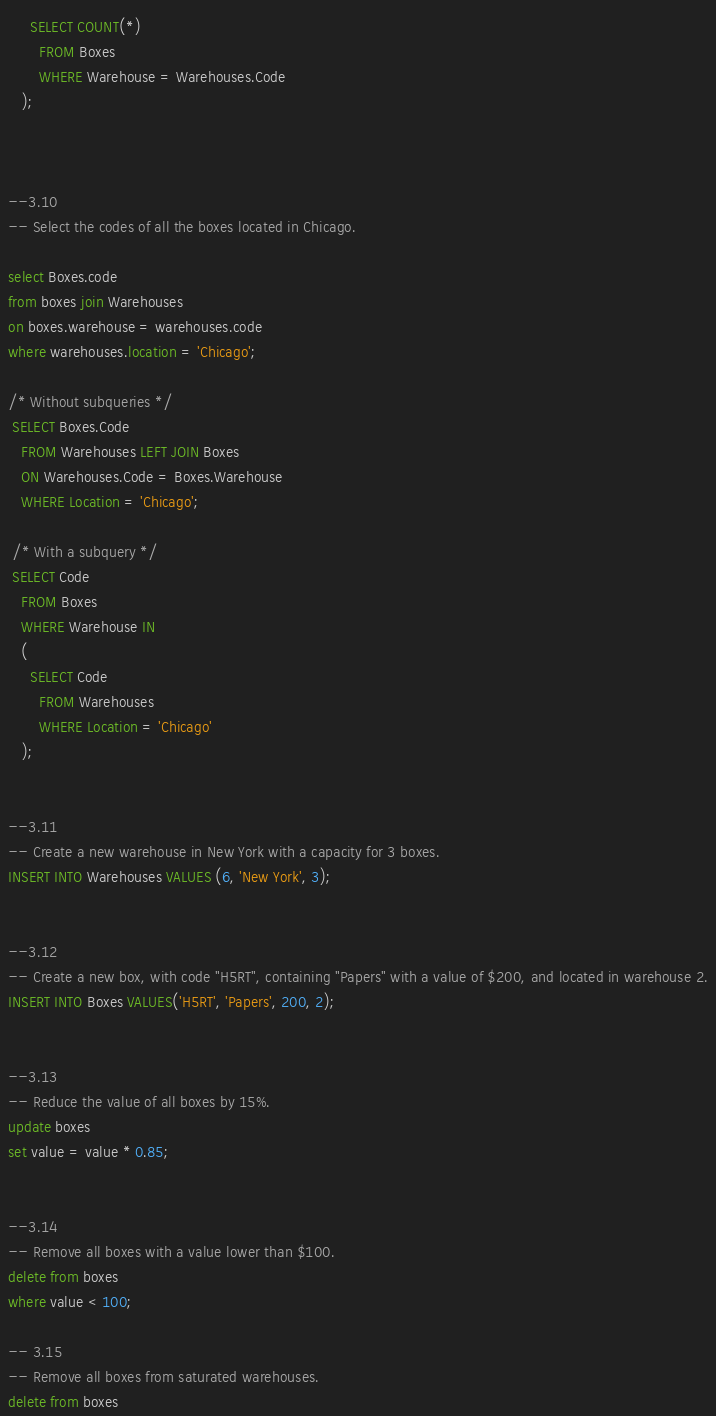Convert code to text. <code><loc_0><loc_0><loc_500><loc_500><_SQL_>     SELECT COUNT(*)
       FROM Boxes
       WHERE Warehouse = Warehouses.Code
   );



--3.10
-- Select the codes of all the boxes located in Chicago.

select Boxes.code 
from boxes join Warehouses
on boxes.warehouse = warehouses.code
where warehouses.location = 'Chicago';

/* Without subqueries */
 SELECT Boxes.Code
   FROM Warehouses LEFT JOIN Boxes
   ON Warehouses.Code = Boxes.Warehouse
   WHERE Location = 'Chicago';

 /* With a subquery */
 SELECT Code
   FROM Boxes
   WHERE Warehouse IN
   (
     SELECT Code
       FROM Warehouses
       WHERE Location = 'Chicago'
   );


--3.11
-- Create a new warehouse in New York with a capacity for 3 boxes.
INSERT INTO Warehouses VALUES (6, 'New York', 3);


--3.12
-- Create a new box, with code "H5RT", containing "Papers" with a value of $200, and located in warehouse 2.
INSERT INTO Boxes VALUES('H5RT', 'Papers', 200, 2);


--3.13
-- Reduce the value of all boxes by 15%.
update boxes
set value = value * 0.85;


--3.14
-- Remove all boxes with a value lower than $100.
delete from boxes 
where value < 100;

-- 3.15
-- Remove all boxes from saturated warehouses.
delete from boxes</code> 